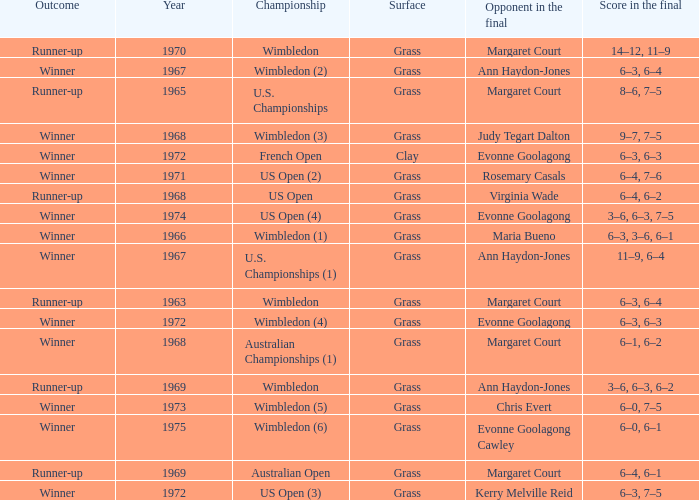What was the final score of the Australian Open? 6–4, 6–1. 